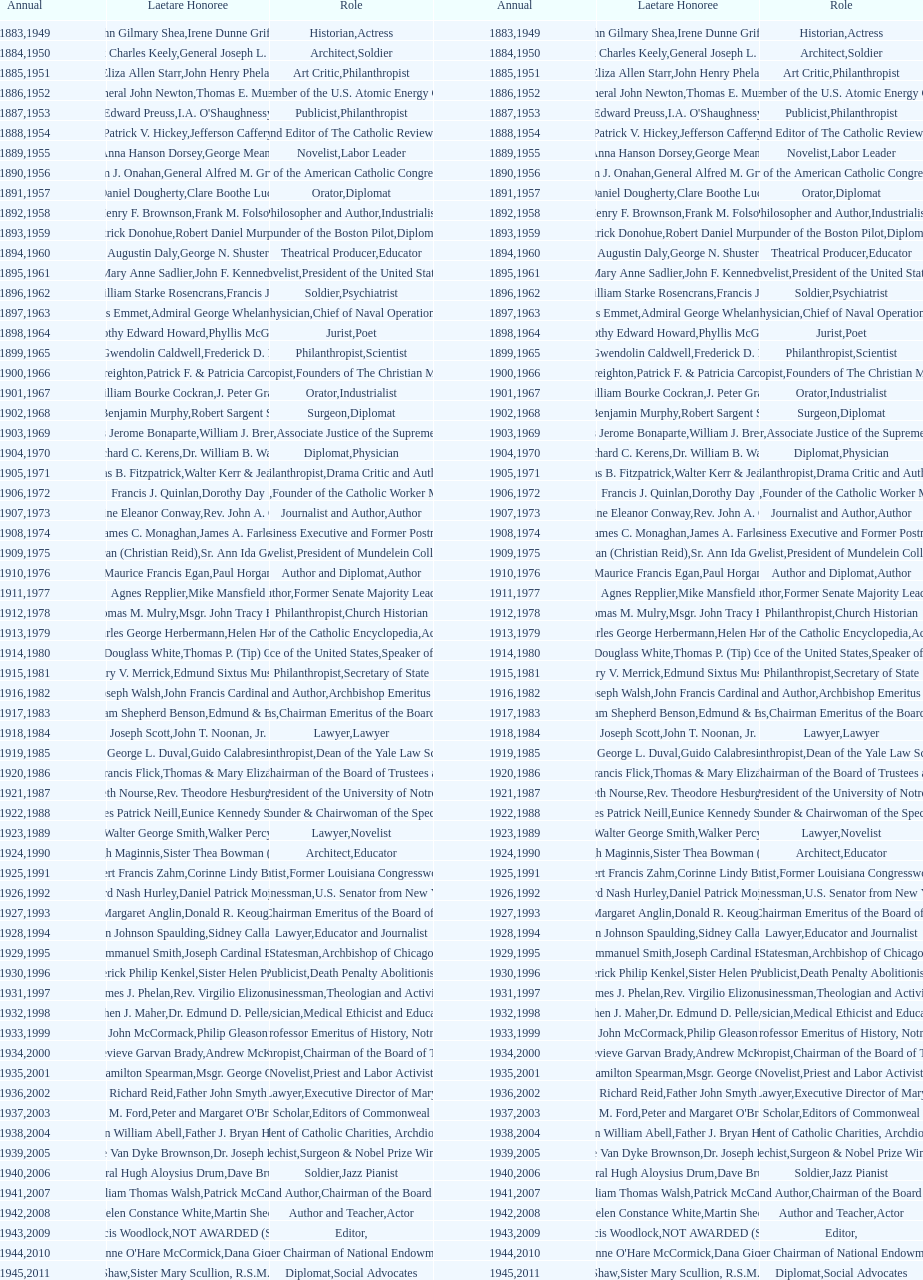Who was the previous winner before john henry phelan in 1951? General Joseph L. Collins. 